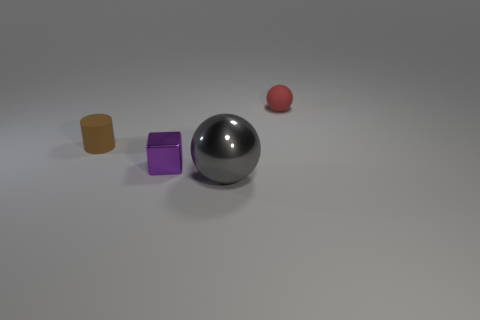What number of objects are balls that are to the right of the gray metal thing or small objects that are to the right of the gray shiny object?
Keep it short and to the point. 1. What is the shape of the tiny red matte object?
Make the answer very short. Sphere. There is a gray thing that is the same shape as the small red thing; what is its size?
Offer a very short reply. Large. The purple object that is on the left side of the shiny thing to the right of the small thing in front of the cylinder is made of what material?
Offer a terse response. Metal. Are there any large blue balls?
Your answer should be compact. No. Is the color of the small rubber sphere the same as the ball in front of the matte ball?
Provide a succinct answer. No. The tiny ball is what color?
Provide a short and direct response. Red. Is there anything else that has the same shape as the purple metal object?
Offer a terse response. No. What is the color of the large object that is the same shape as the small red object?
Your answer should be compact. Gray. Is the tiny brown object the same shape as the small red rubber object?
Make the answer very short. No. 